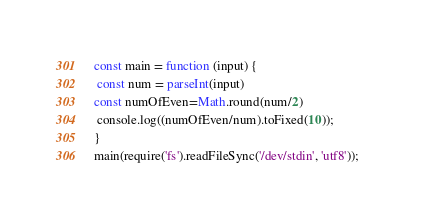<code> <loc_0><loc_0><loc_500><loc_500><_JavaScript_>const main = function (input) {
 const num = parseInt(input)
const numOfEven=Math.round(num/2)
 console.log((numOfEven/num).toFixed(10));
}
main(require('fs').readFileSync('/dev/stdin', 'utf8'));  </code> 